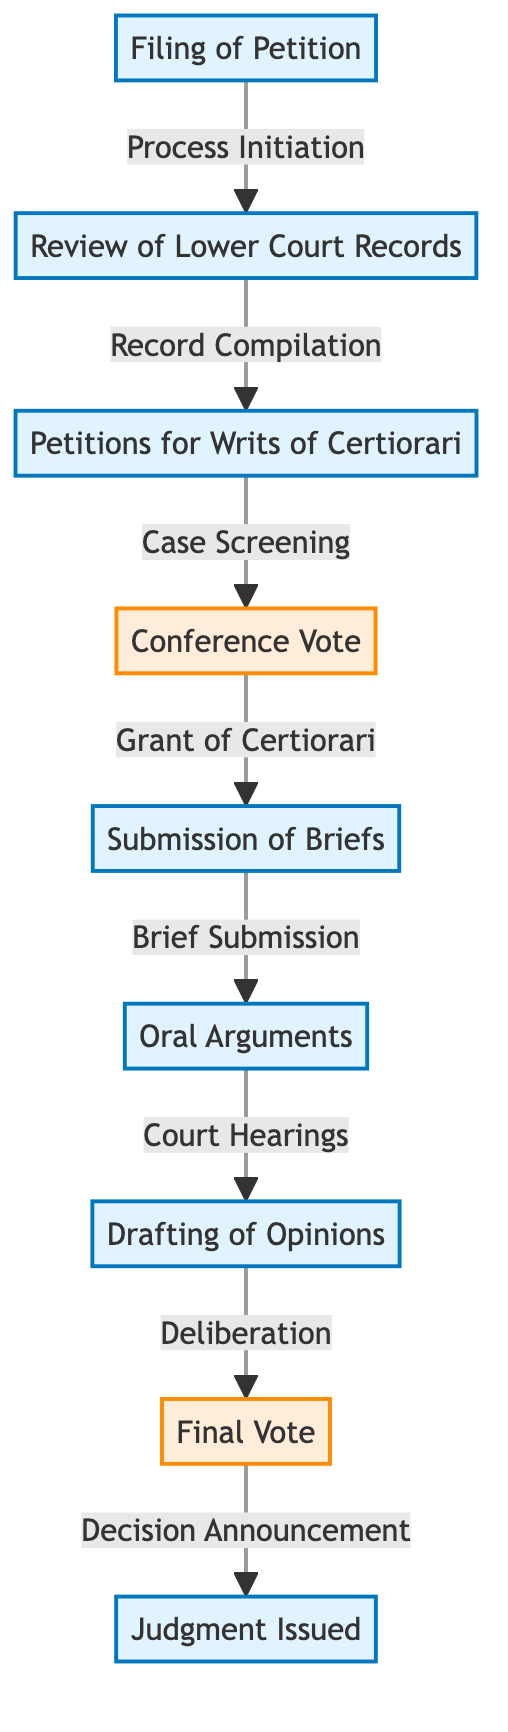What is the first step in the flow of a Supreme Court case? The first step in the flow is "Filing of Petition," which initiates the legal process in the Supreme Court. This is represented as the starting node in the diagram.
Answer: Filing of Petition How many steps are there in the flowchart from filing to judgment? By counting all the distinct steps shown in the flowchart, including both process steps and judgment, we find there are eight steps represented.
Answer: 8 What happens after the "Conference Vote"? After the "Conference Vote," the diagram indicates that the next step is "Submission of Briefs," which implies that brief submissions occur following the conference's decision.
Answer: Submission of Briefs What is the last step before the final judgment? The last step before the final judgment is "Final Vote," which indicates that after deliberation and opinion drafting, the court makes a conclusive vote before delivering the judgment.
Answer: Final Vote What type of motion is filed to seek Supreme Court review? The motion filed to seek review by the Supreme Court is termed "Petitions for Writs of Certiorari," as displayed in the flowchart.
Answer: Petitions for Writs of Certiorari Which step follows "Oral Arguments"? The step that follows "Oral Arguments" is "Drafting of Opinions," indicating that after hearing arguments, the court drafts its opinions on the case.
Answer: Drafting of Opinions How does the "Review of Lower Court Records" relate to the "Filing of Petition"? The relationship is sequential; "Review of Lower Court Records" follows the "Filing of Petition," as it is the second step in the flow, directly stemming from the initiation of the process.
Answer: It follows What is the significance of "Grant of Certiorari"? The "Grant of Certiorari" signifies a critical decision point, as it determines whether the Supreme Court will hear the case after the initial screening of the petitions.
Answer: Critical decision point What does the diagram suggest happens during the "Deliberation"? The diagram suggests that during "Deliberation," the justices discuss and evaluate the case before drafting the final opinion, leading into the final voting process.
Answer: Justices discuss and evaluate the case 